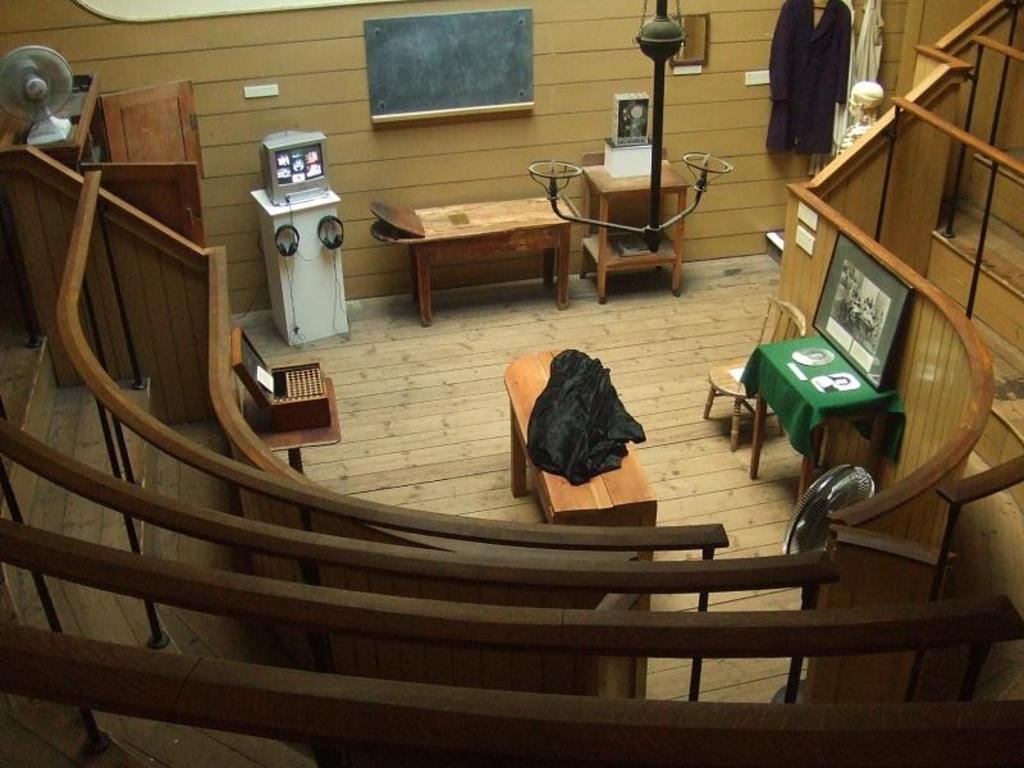What type of furniture is present in the image? There are wooden tables and chairs in the image. Can you describe any decorative items in the image? There is a photo frame on one table. What type of electronic device is visible in the image? There is a television in the image. What is used for listening to audio in the image? There are headphones in the image. How can you access the upper level in the image? There are wooden stairs in the image. What type of clothing is visible in the image? There are clothes in the image. What type of storage furniture is present in the image? There is a cupboard in the image. What type of cooling device is present in the image? There is a table fan in the image. Can you describe any unspecified objects in the image? There are some unspecified objects in the image. Reasoning: Let'ing: Let's think step by step in order to produce the conversation. We start by identifying the main furniture items in the image, which are the wooden tables and chairs. Then, we expand the conversation to include other items that are also visible, such as the photo frame, television, headphones, wooden stairs, clothes, cupboard, table fan, and unspecified objects. Each question is designed to elicit a specific detail about the image that is known from the provided facts. Absurd Question/Answer: What type of trucks can be seen driving on the floor in the image? There are no trucks visible in the image, and the floor is not mentioned in the provided facts. 